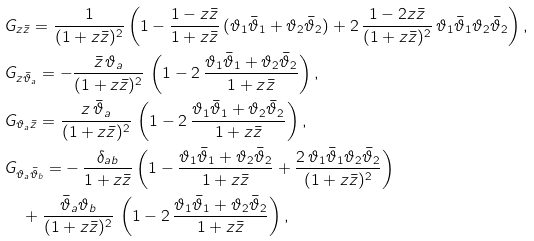<formula> <loc_0><loc_0><loc_500><loc_500>& G _ { z \bar { z } } = \frac { 1 } { ( 1 + z \bar { z } ) ^ { 2 } } \left ( 1 - \frac { 1 - z \bar { z } } { 1 + z \bar { z } } \, ( \vartheta _ { 1 } \bar { \vartheta } _ { 1 } + \vartheta _ { 2 } \bar { \vartheta } _ { 2 } ) + 2 \, \frac { 1 - 2 z \bar { z } } { ( 1 + z \bar { z } ) ^ { 2 } } \, \vartheta _ { 1 } \bar { \vartheta } _ { 1 } \vartheta _ { 2 } \bar { \vartheta } _ { 2 } \right ) , \\ & G _ { z \bar { \vartheta } _ { a } } = - \frac { \bar { z } \, \vartheta _ { a } } { ( 1 + z \bar { z } ) ^ { 2 } } \, \left ( 1 - 2 \, \frac { \vartheta _ { 1 } \bar { \vartheta } _ { 1 } + \vartheta _ { 2 } \bar { \vartheta } _ { 2 } } { 1 + z \bar { z } } \right ) , \\ & G _ { \vartheta _ { a } \bar { z } } = \frac { z \, \bar { \vartheta } _ { a } } { ( 1 + z \bar { z } ) ^ { 2 } } \, \left ( 1 - 2 \, \frac { \vartheta _ { 1 } \bar { \vartheta } _ { 1 } + \vartheta _ { 2 } \bar { \vartheta } _ { 2 } } { 1 + z \bar { z } } \right ) , \\ & G _ { \vartheta _ { a } \bar { \vartheta } _ { b } } = - \, \frac { \delta _ { a b } } { 1 + z \bar { z } } \left ( 1 - \frac { \vartheta _ { 1 } \bar { \vartheta } _ { 1 } + \vartheta _ { 2 } \bar { \vartheta } _ { 2 } } { 1 + z \bar { z } } + \frac { 2 \, \vartheta _ { 1 } \bar { \vartheta } _ { 1 } \vartheta _ { 2 } \bar { \vartheta } _ { 2 } } { ( 1 + z \bar { z } ) ^ { 2 } } \right ) \\ & \quad + \frac { \bar { \vartheta } _ { a } \vartheta _ { b } } { ( 1 + z \bar { z } ) ^ { 2 } } \, \left ( 1 - 2 \, \frac { \vartheta _ { 1 } \bar { \vartheta } _ { 1 } + \vartheta _ { 2 } \bar { \vartheta } _ { 2 } } { 1 + z \bar { z } } \right ) , \\</formula> 